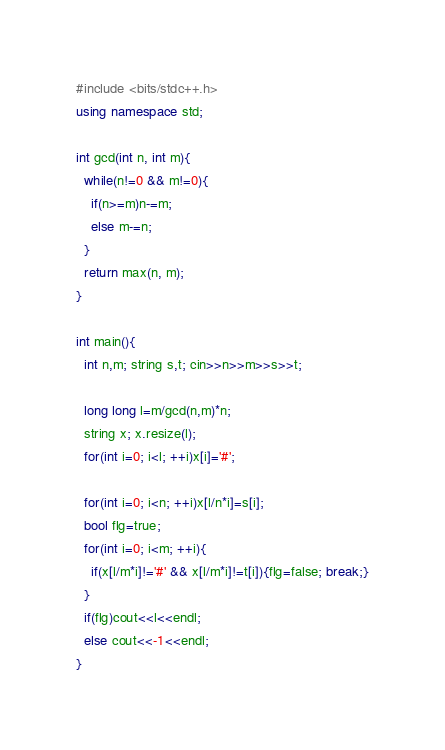<code> <loc_0><loc_0><loc_500><loc_500><_C++_>#include <bits/stdc++.h>
using namespace std;

int gcd(int n, int m){
  while(n!=0 && m!=0){
    if(n>=m)n-=m;
    else m-=n;
  }
  return max(n, m);
}

int main(){
  int n,m; string s,t; cin>>n>>m>>s>>t;

  long long l=m/gcd(n,m)*n;
  string x; x.resize(l);
  for(int i=0; i<l; ++i)x[i]='#';

  for(int i=0; i<n; ++i)x[l/n*i]=s[i];
  bool flg=true;
  for(int i=0; i<m; ++i){
    if(x[l/m*i]!='#' && x[l/m*i]!=t[i]){flg=false; break;}
  }
  if(flg)cout<<l<<endl;
  else cout<<-1<<endl;
}</code> 